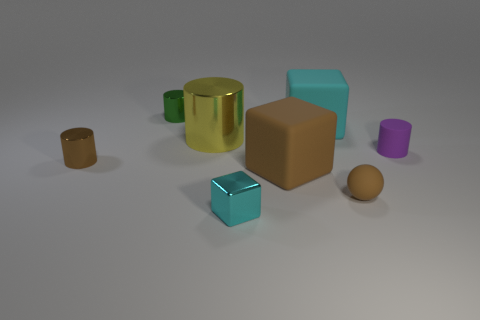Subtract all large cyan matte cubes. How many cubes are left? 2 Subtract all purple cylinders. How many cyan cubes are left? 2 Add 1 cyan things. How many objects exist? 9 Subtract 1 balls. How many balls are left? 0 Subtract all brown blocks. How many blocks are left? 2 Subtract all balls. How many objects are left? 7 Subtract 0 yellow cubes. How many objects are left? 8 Subtract all gray spheres. Subtract all blue cylinders. How many spheres are left? 1 Subtract all big purple cylinders. Subtract all purple things. How many objects are left? 7 Add 7 large yellow things. How many large yellow things are left? 8 